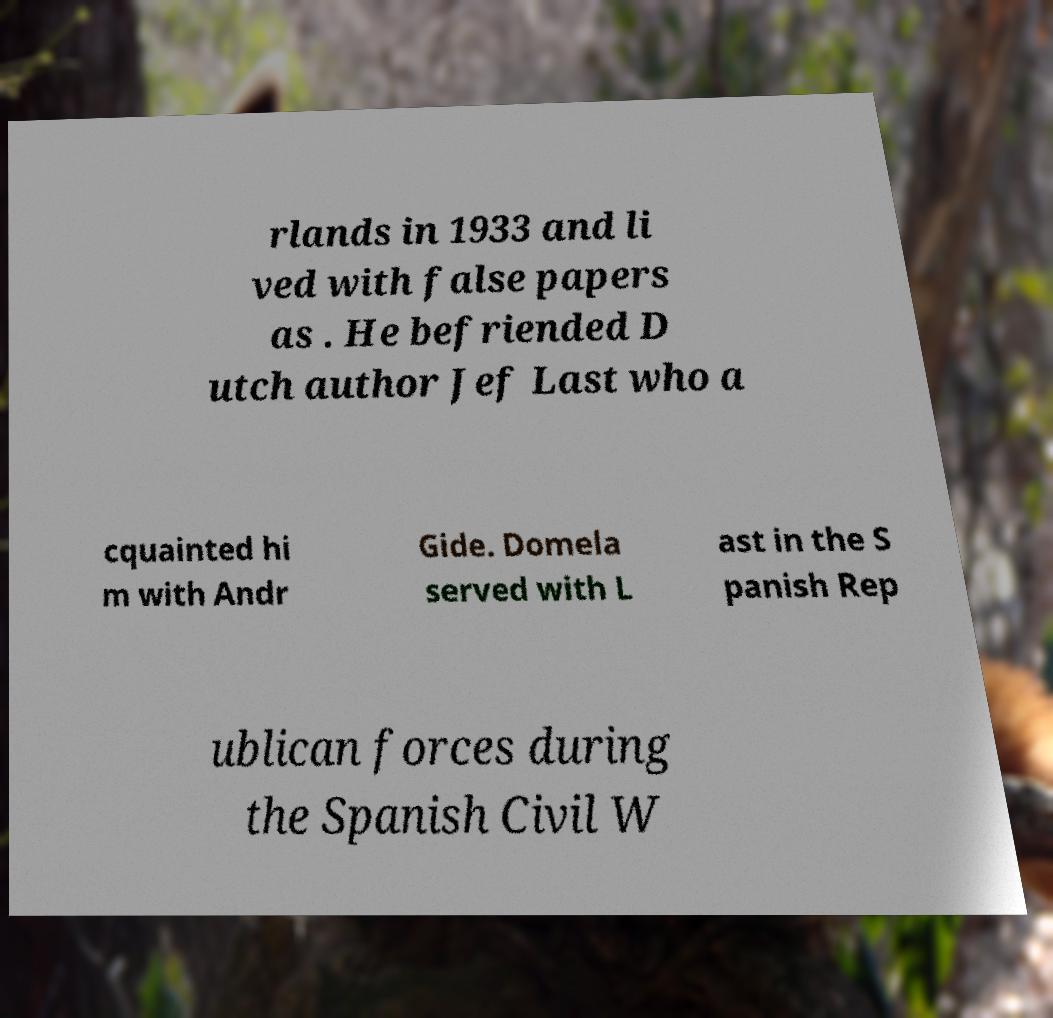Please identify and transcribe the text found in this image. rlands in 1933 and li ved with false papers as . He befriended D utch author Jef Last who a cquainted hi m with Andr Gide. Domela served with L ast in the S panish Rep ublican forces during the Spanish Civil W 